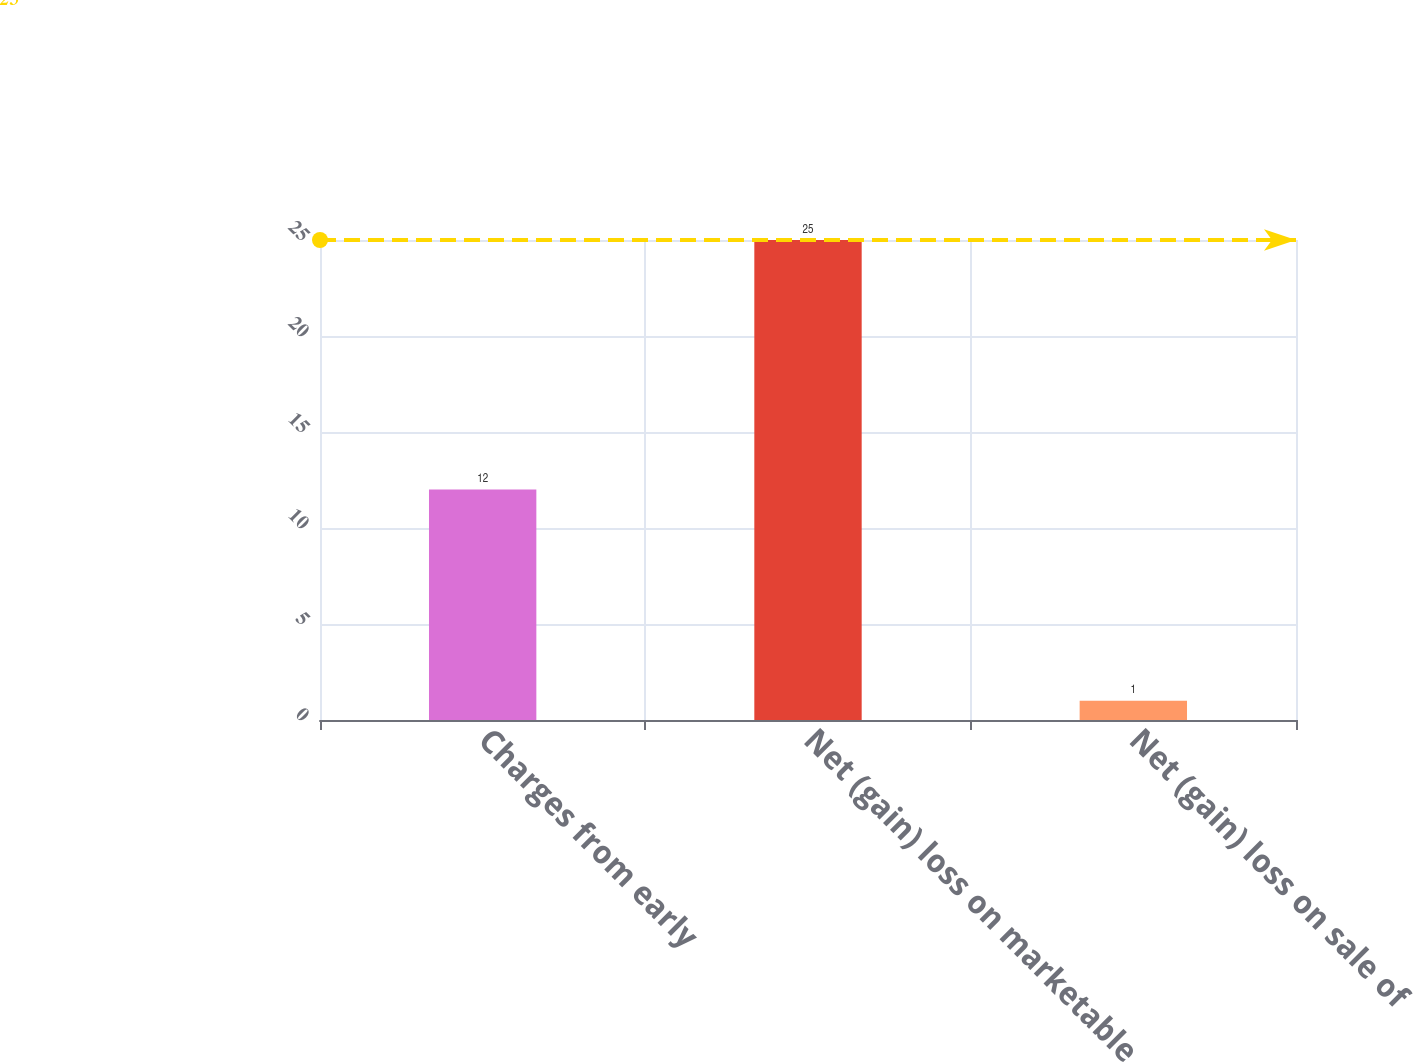<chart> <loc_0><loc_0><loc_500><loc_500><bar_chart><fcel>Charges from early<fcel>Net (gain) loss on marketable<fcel>Net (gain) loss on sale of<nl><fcel>12<fcel>25<fcel>1<nl></chart> 